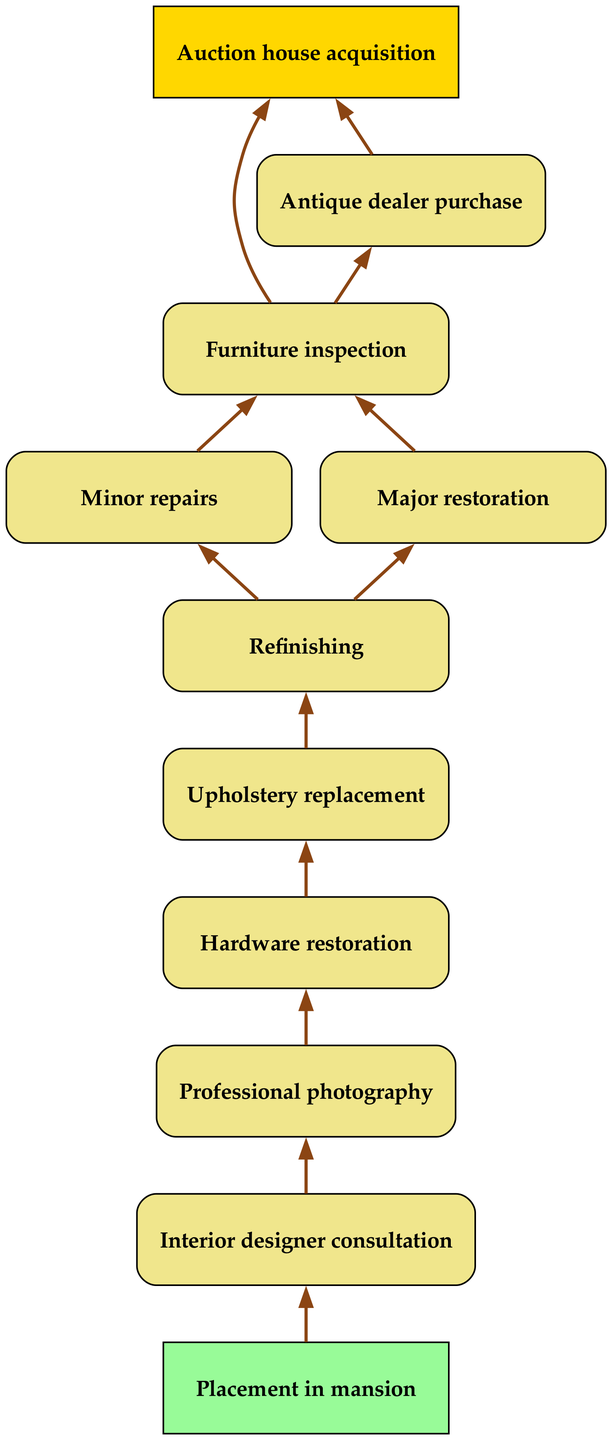What is the starting point of the restoration process? The diagram indicates that the starting point is "Auction house acquisition." This is the first node in the flow chart, leading to subsequent steps in the restoration process.
Answer: Auction house acquisition How many major stages are there in the restoration process? Counting the main nodes that represent distinct steps (from acquisition to placement), there are a total of 11 stages in the restoration process.
Answer: 11 What type of restoration follows "Furniture inspection"? The diagram shows that after "Furniture inspection," there are two potential paths: "Minor repairs" and "Major restoration." This means that either of these follow-ups can occur based on the assessment of the antique furniture.
Answer: Minor repairs or Major restoration Which step comes directly after "Refinishing"? Looking at the flow chart, the step that directly follows "Refinishing" is "Upholstery replacement." This sequential order indicates the natural progression in the restoration process after refinishing the furniture's surface.
Answer: Upholstery replacement What is the final step before placement in the mansion? According to the diagram, "Interior designer consultation" is the step that comes right before "Placement in mansion." This indicates that consulting with an interior designer is an important final preparation before placing the restored furniture.
Answer: Interior designer consultation Which step has the most immediate follow-up action? The step "Furniture inspection" has two immediate follow-up actions: "Minor repairs" and "Major restoration." This indicates that after inspecting the furniture, a decision must be made about the level of restoration needed, making it a critical point in the process.
Answer: Minor repairs and Major restoration How do you move from "Hardware restoration" to the next step? The diagram illustrates that after "Hardware restoration," the next step is "Professional photography." This shows that documenting the restored piece is a priority following its hardware enhancements.
Answer: Professional photography What color represents the starting and ending nodes in the diagram? The starting node "Auction house acquisition" is represented in gold, while the ending node "Placement in mansion" is in light green. The color coding emphasizes the start and finish of the restoration process visually.
Answer: Gold and light green What is the last action in the restoration process? The concluding action in the restoration process is "Placement in mansion." This marks the ultimate goal of the entire restoration effort, which is placing the restored furniture within the home.
Answer: Placement in mansion 